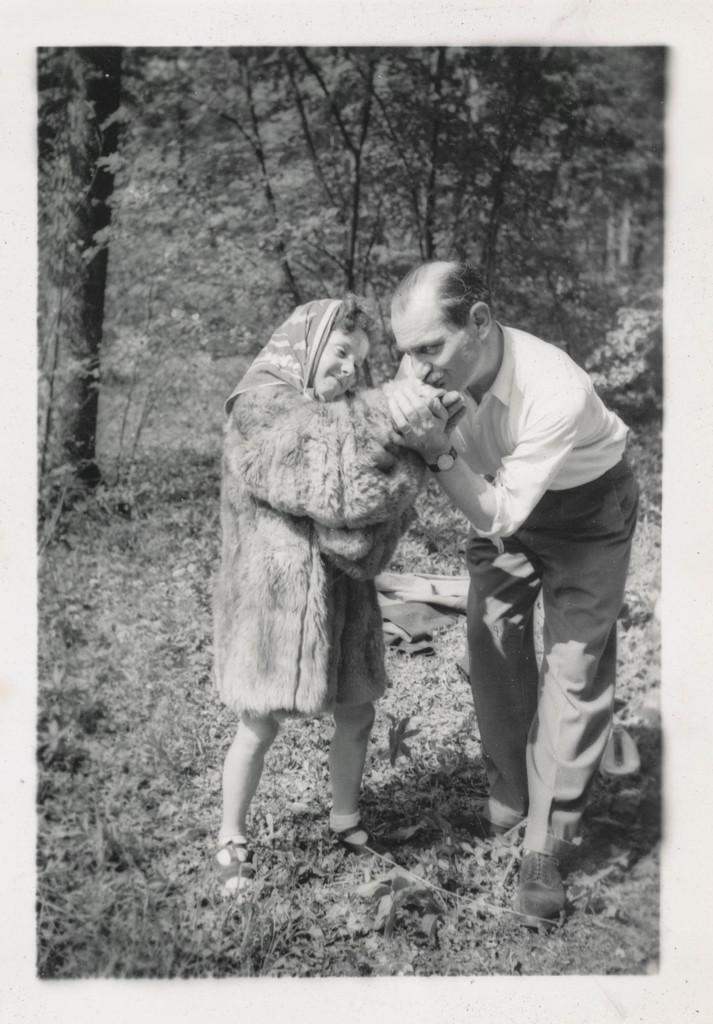In one or two sentences, can you explain what this image depicts? In this black and white image, there is a small girl and a man in the foreground and there are trees in the background. 